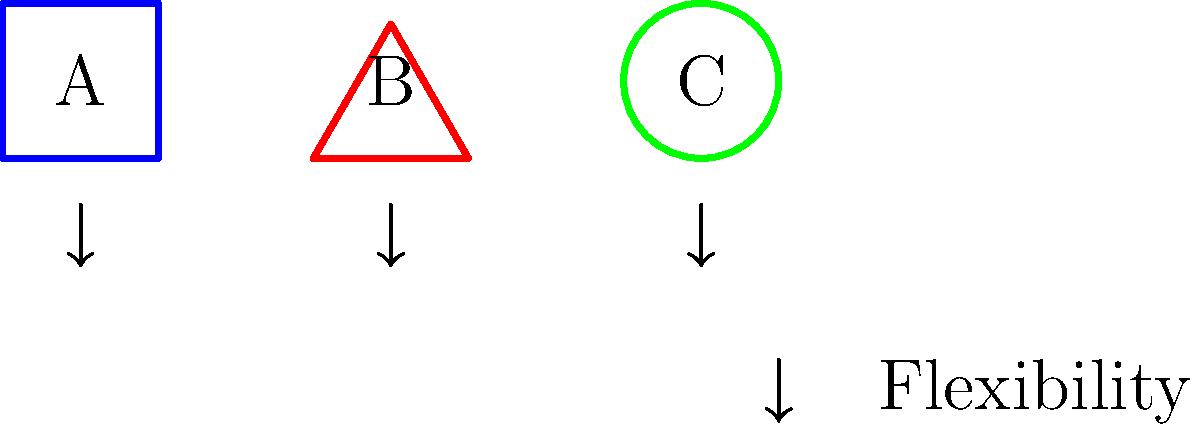In the context of historical battle formations, which of the depicted shapes (A, B, or C) would likely offer the greatest strategic advantage in terms of flexibility and adaptability to changing battlefield conditions? Explain your reasoning based on topological properties. To answer this question, we need to analyze the topological properties of each formation:

1. Formation A (Square):
   - Rigid structure with fixed edges and corners
   - Limited flexibility due to its defined shape
   - Offers strong defense but less adaptability

2. Formation B (Triangle):
   - Three distinct points (vertices) connected by straight edges
   - More flexible than the square, allowing for directional focus
   - Can easily transform into a line or adapt to terrain

3. Formation C (Circle):
   - No corners or edges, continuous curve
   - Highest degree of topological flexibility
   - Can easily expand, contract, or morph into other shapes

Analyzing the flexibility:
- The circle (C) has the highest degree of symmetry and can be rotated or deformed without changing its fundamental properties.
- It can easily adapt to various terrains and battlefield conditions.
- The circular formation allows for quick repositioning of troops in any direction.
- Topologically, a circle can be continuously deformed into any other closed curve without breaking or creating new holes, making it the most adaptable.

In military strategy, flexibility often translates to:
1. Ability to quickly respond to enemy movements
2. Ease of maintaining formation cohesion during maneuvers
3. Adaptability to different terrains and unexpected situations

While all formations have their uses in specific scenarios, the circular formation (C) offers the greatest overall flexibility and adaptability from a topological perspective.
Answer: C (Circle) 